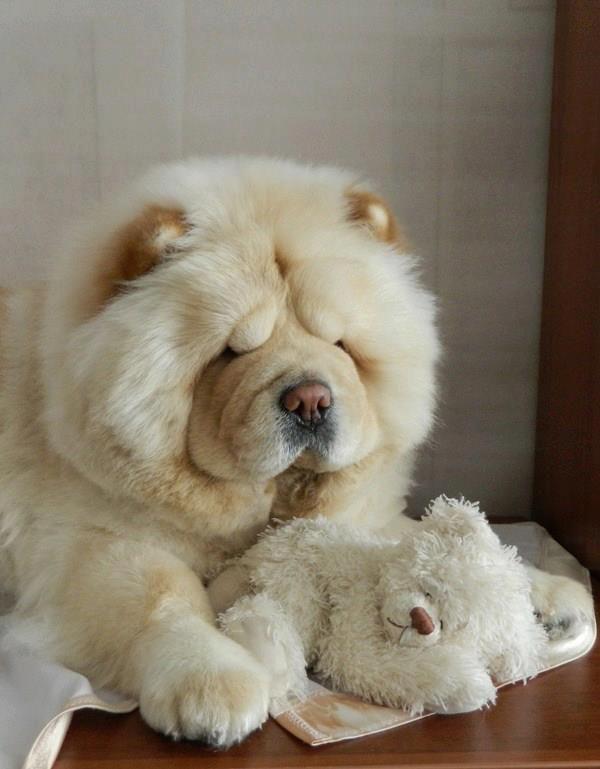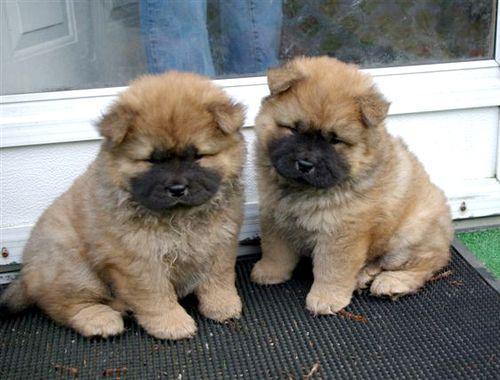The first image is the image on the left, the second image is the image on the right. For the images displayed, is the sentence "There is a dog with a stuffed animal in the image on the left." factually correct? Answer yes or no. Yes. 